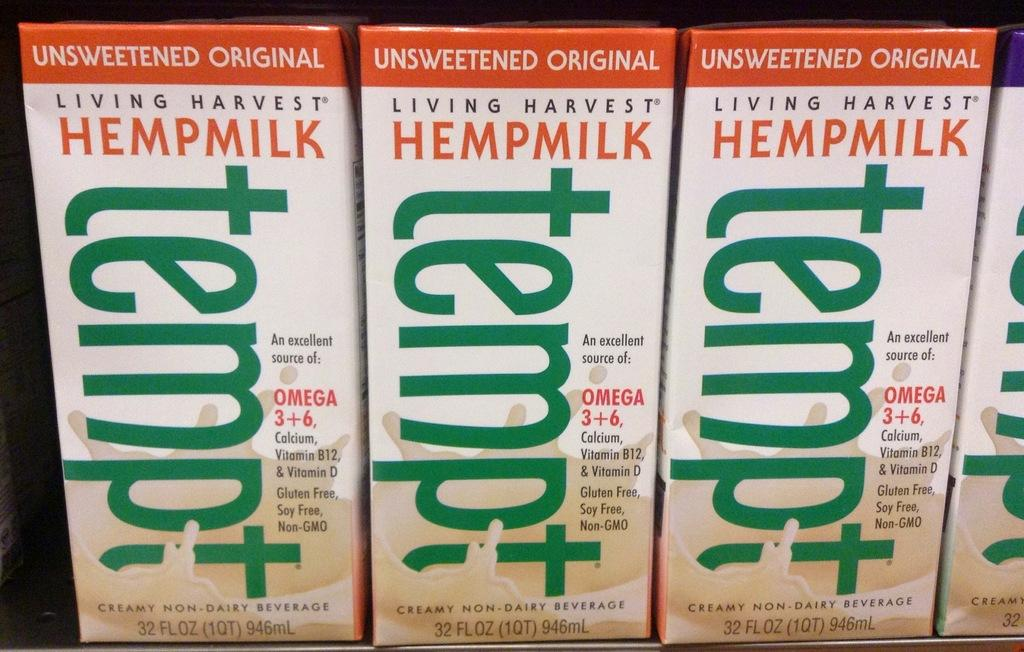<image>
Share a concise interpretation of the image provided. A row of Unsweetened Original Hemp milk called Tempt. 